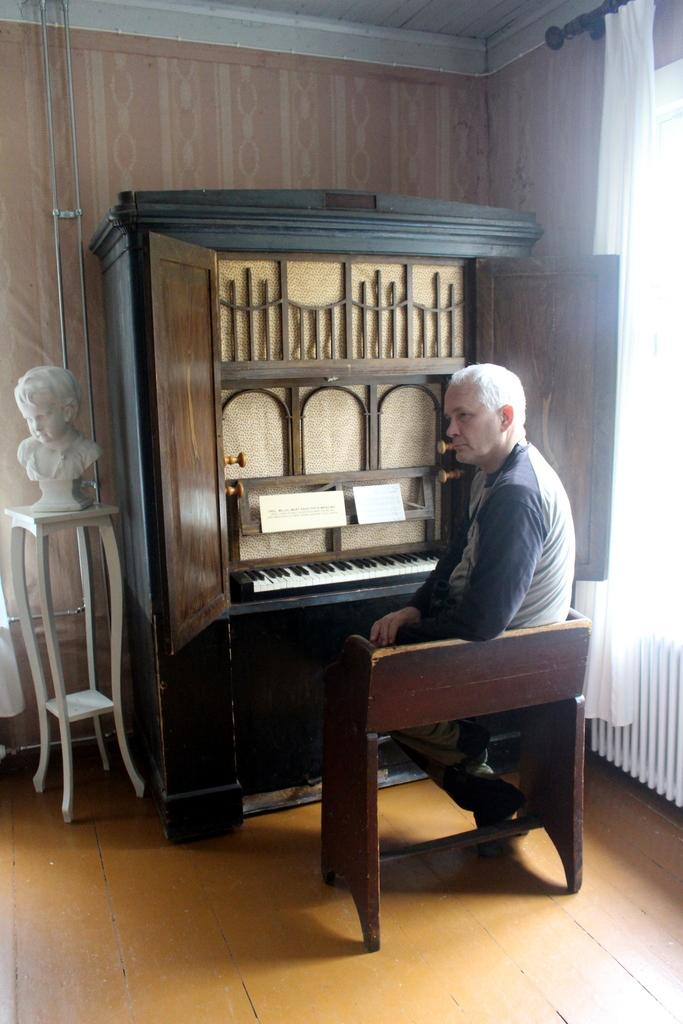Who is the main subject in the image? There is a man in the image. What is the man doing in the image? The man is sitting. What object is in front of the man? The man is in front of a musical keyboard. What type of star can be seen shining brightly in the image? There is no star visible in the image; it features a man sitting in front of a musical keyboard. 